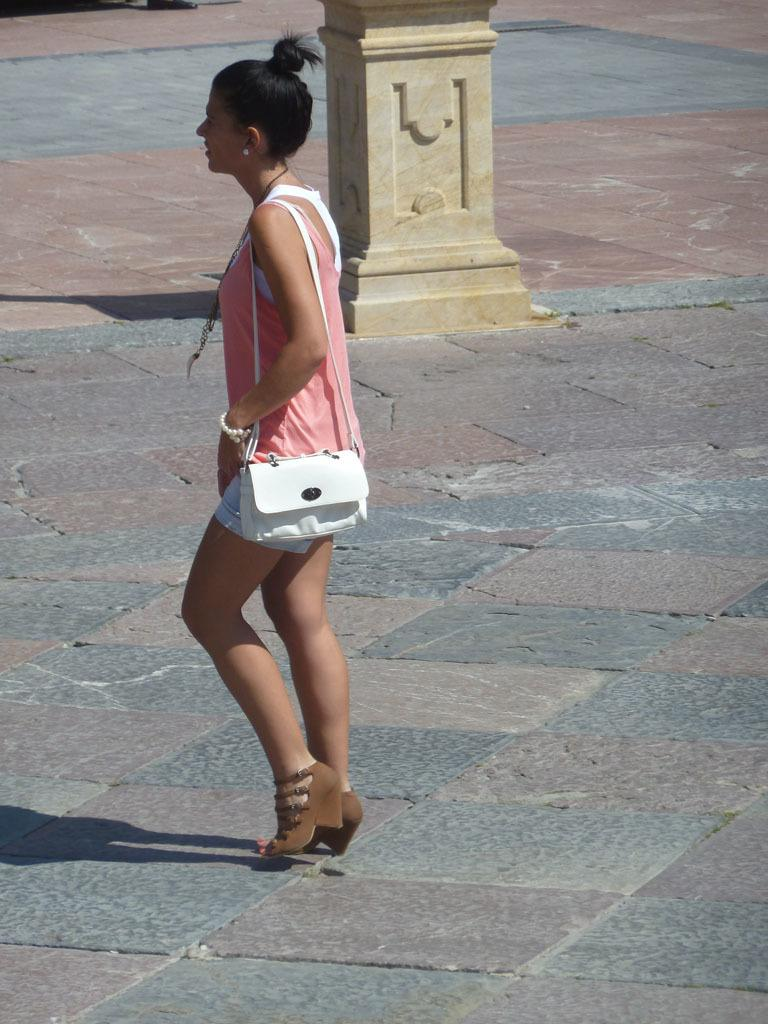Who is present in the image? There is a woman in the image. What is the woman standing on? The woman is standing on a stone path. What type of footwear is the woman wearing? The woman is wearing heels. What is the woman carrying in the image? The woman is carrying a bag. What type of sea creature can be seen in the woman's stomach in the image? There is no sea creature present in the image, nor is there any indication that the woman's stomach is visible. 